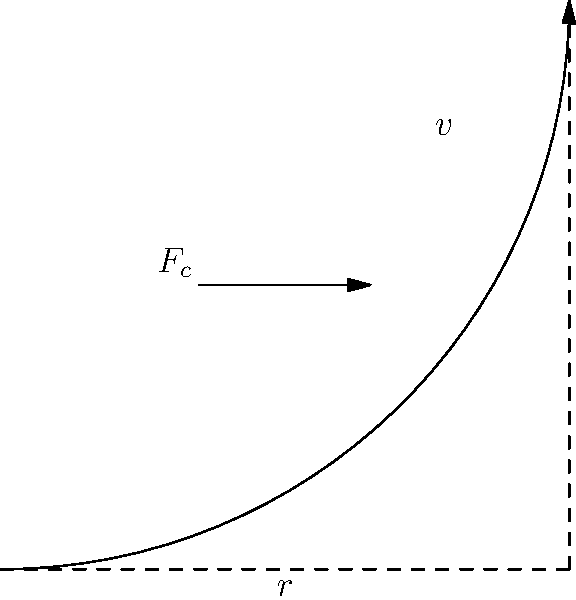During a high-speed training session, Martin van Steen was cornering on a circular track with a radius of 25 meters. If he maintained a speed of 15 m/s, what was the centripetal force acting on him and his bicycle if their combined mass was 80 kg? Assume the track is perfectly level. To solve this problem, we'll use the formula for centripetal force:

$$F_c = \frac{mv^2}{r}$$

Where:
- $F_c$ is the centripetal force
- $m$ is the mass of Martin and his bicycle
- $v$ is the velocity
- $r$ is the radius of the circular path

Let's plug in the values:

1. Mass $(m) = 80$ kg
2. Velocity $(v) = 15$ m/s
3. Radius $(r) = 25$ m

Now, let's calculate:

$$F_c = \frac{80 \text{ kg} \times (15 \text{ m/s})^2}{25 \text{ m}}$$

$$F_c = \frac{80 \times 225}{25} \text{ N}$$

$$F_c = 720 \text{ N}$$

Therefore, the centripetal force acting on Martin van Steen and his bicycle during the corner was 720 Newtons.
Answer: 720 N 